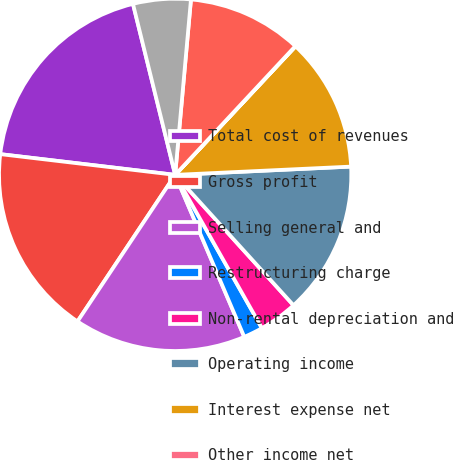Convert chart. <chart><loc_0><loc_0><loc_500><loc_500><pie_chart><fcel>Total cost of revenues<fcel>Gross profit<fcel>Selling general and<fcel>Restructuring charge<fcel>Non-rental depreciation and<fcel>Operating income<fcel>Interest expense net<fcel>Other income net<fcel>Income (loss) from continuing<fcel>Provision (benefit) for income<nl><fcel>19.27%<fcel>17.52%<fcel>15.77%<fcel>1.78%<fcel>3.53%<fcel>14.02%<fcel>12.27%<fcel>0.03%<fcel>10.52%<fcel>5.28%<nl></chart> 